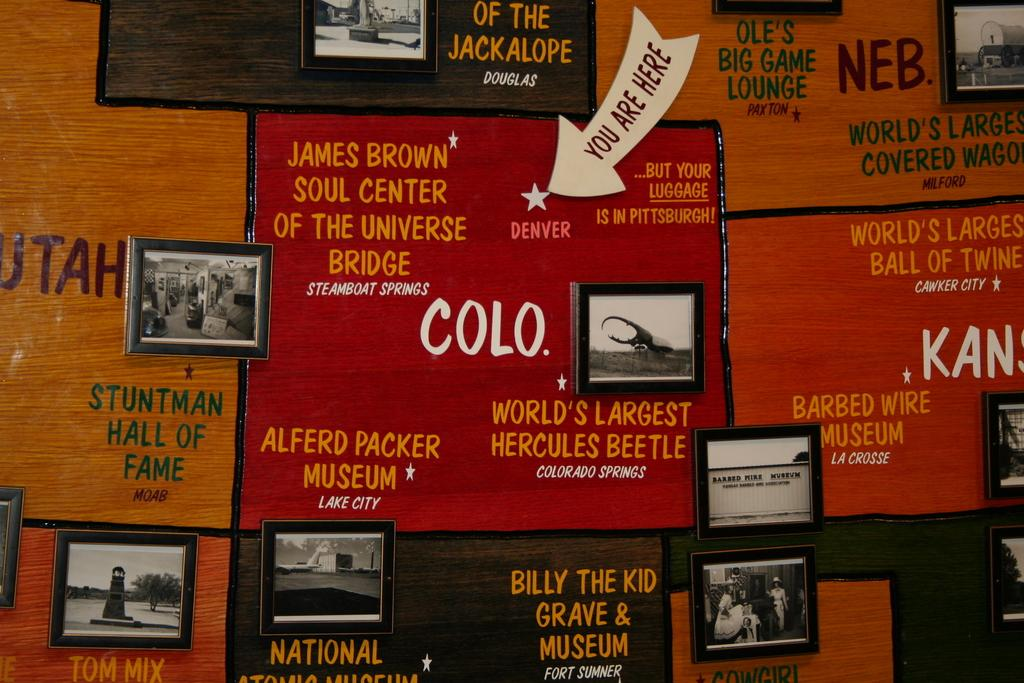Provide a one-sentence caption for the provided image. Ads for museums including one for COLO, the world's largest hercules  beetle. 